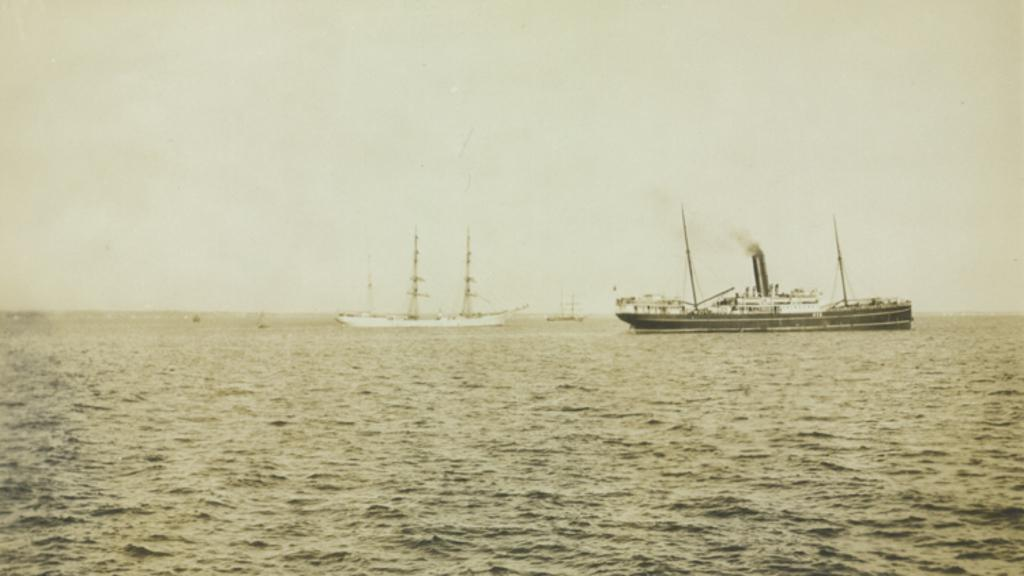What is at the bottom of the image? There is water at the bottom of the image. What type of vehicle is present in the image? There is a ship with poles in the image. What can be seen in the right corner of the image? Smoke is visible in the right corner of the image. How many ships are in the image? There are ships in the image. What else is present in the image besides ships? There are poles in the image. What is visible at the top of the image? The sky is visible at the top of the image. Where is the clover growing in the image? There is no clover present in the image. What type of chain is connecting the ships in the image? There is no chain connecting the ships in the image; they are separate entities. 